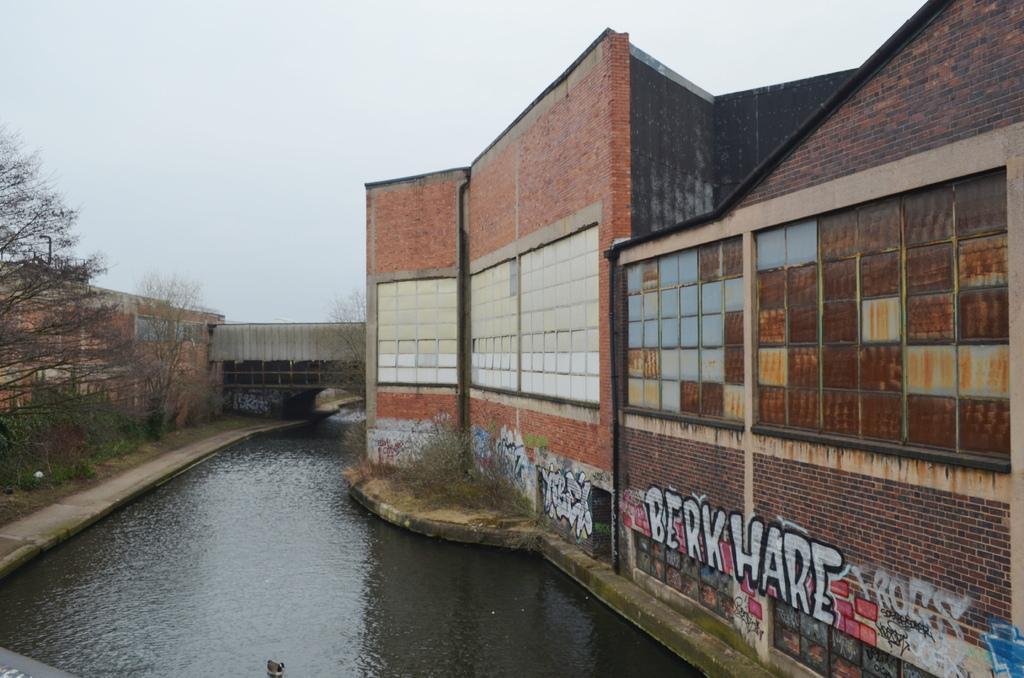Could you give a brief overview of what you see in this image? Here in this picture we can see buildings present all over there and in the middle we can see water present and we can also see a bridge present in the middle and we can see plants and trees present here and there on the ground over there. 